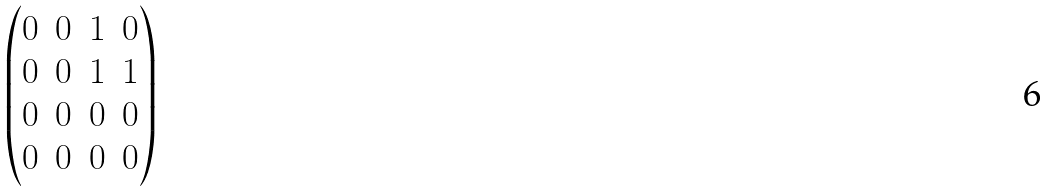Convert formula to latex. <formula><loc_0><loc_0><loc_500><loc_500>\begin{pmatrix} 0 & 0 & 1 & 0 \\ 0 & 0 & 1 & 1 \\ 0 & 0 & 0 & 0 \\ 0 & 0 & 0 & 0 \end{pmatrix}</formula> 